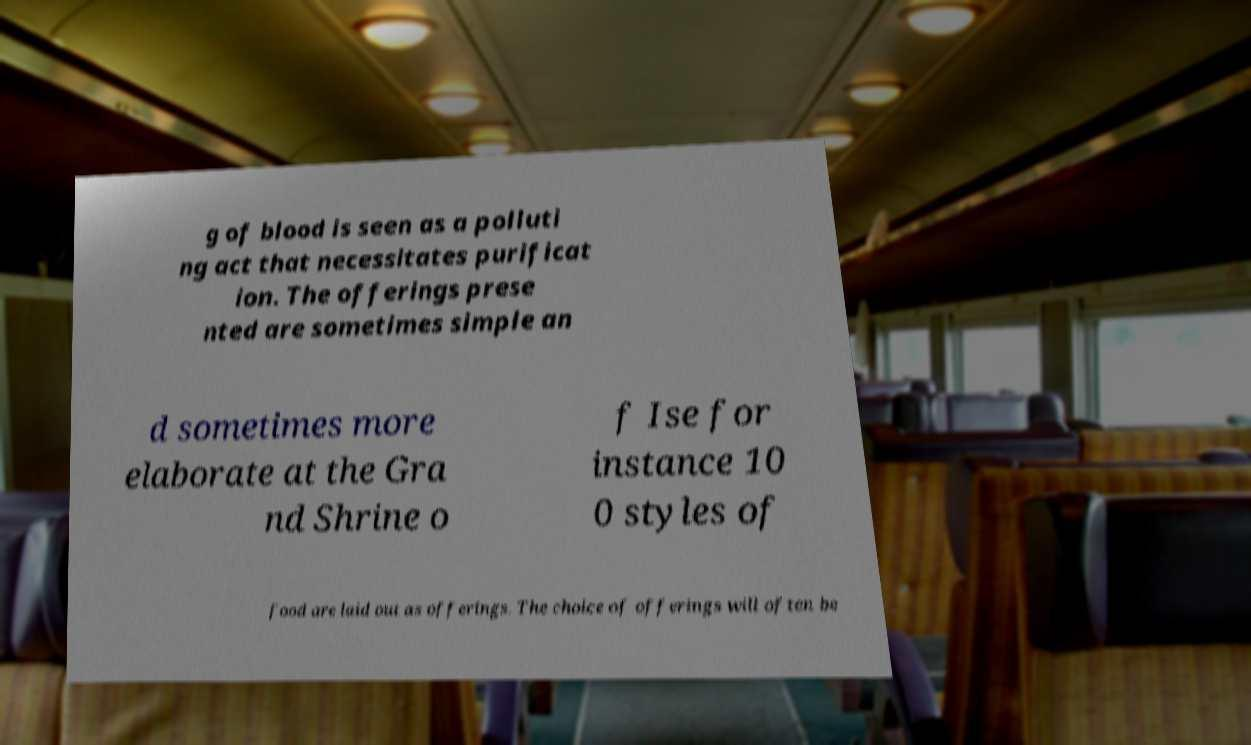I need the written content from this picture converted into text. Can you do that? g of blood is seen as a polluti ng act that necessitates purificat ion. The offerings prese nted are sometimes simple an d sometimes more elaborate at the Gra nd Shrine o f Ise for instance 10 0 styles of food are laid out as offerings. The choice of offerings will often be 